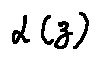<formula> <loc_0><loc_0><loc_500><loc_500>\alpha ( z )</formula> 